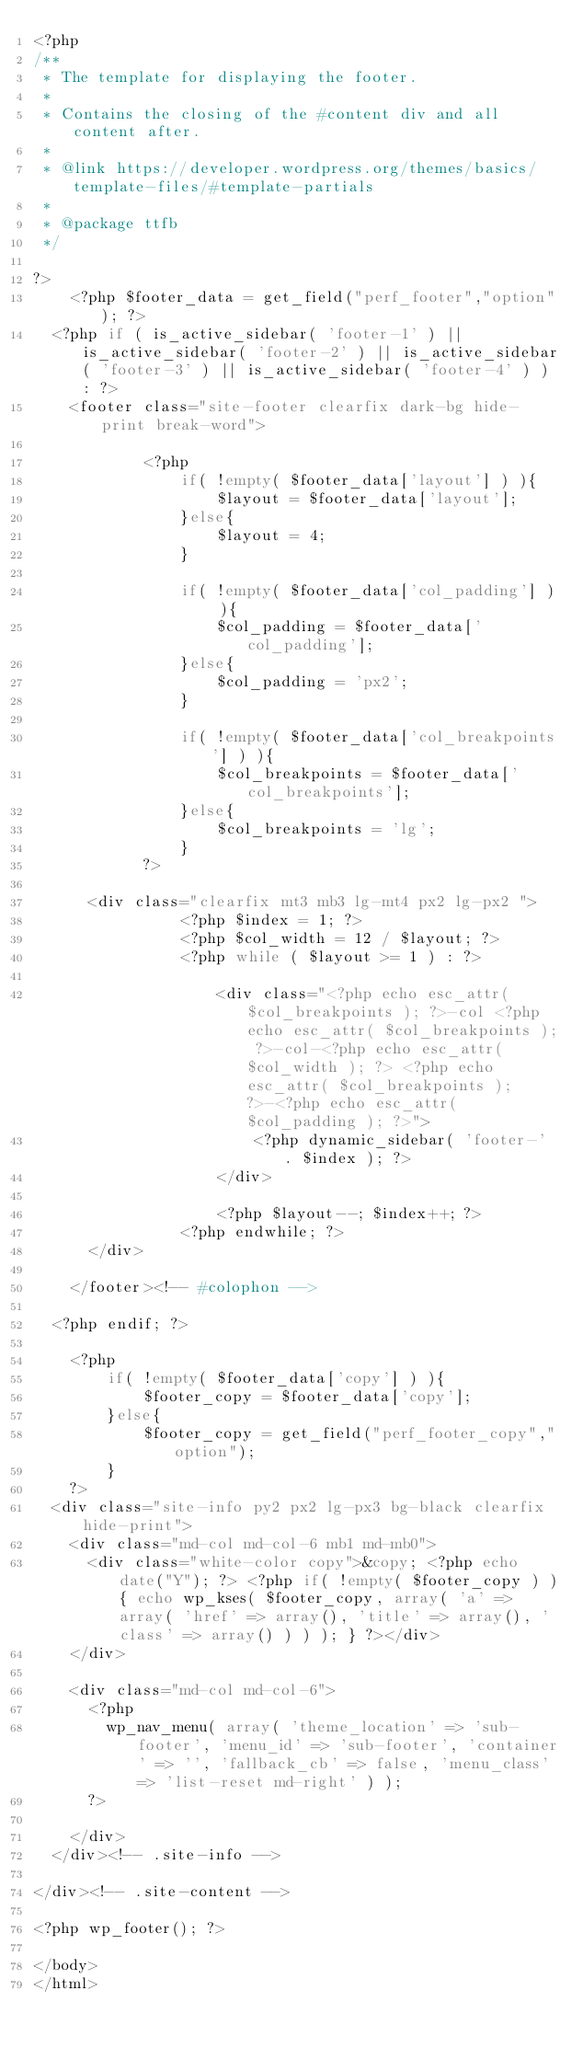Convert code to text. <code><loc_0><loc_0><loc_500><loc_500><_PHP_><?php
/**
 * The template for displaying the footer.
 *
 * Contains the closing of the #content div and all content after.
 *
 * @link https://developer.wordpress.org/themes/basics/template-files/#template-partials
 *
 * @package ttfb
 */

?>
    <?php $footer_data = get_field("perf_footer","option"); ?>
	<?php if ( is_active_sidebar( 'footer-1' ) || is_active_sidebar( 'footer-2' ) || is_active_sidebar( 'footer-3' ) || is_active_sidebar( 'footer-4' ) ) : ?>
		<footer class="site-footer clearfix dark-bg hide-print break-word">

            <?php 
                if( !empty( $footer_data['layout'] ) ){
                    $layout = $footer_data['layout'];
                }else{
                    $layout = 4;
                }

                if( !empty( $footer_data['col_padding'] ) ){
                    $col_padding = $footer_data['col_padding'];
                }else{
                    $col_padding = 'px2';
                }

                if( !empty( $footer_data['col_breakpoints'] ) ){
                    $col_breakpoints = $footer_data['col_breakpoints'];
                }else{
                    $col_breakpoints = 'lg';
                }
            ?>
            
			<div class="clearfix mt3 mb3 lg-mt4 px2 lg-px2 ">
                <?php $index = 1; ?>
                <?php $col_width = 12 / $layout; ?>
                <?php while ( $layout >= 1 ) : ?>
                
                    <div class="<?php echo esc_attr( $col_breakpoints ); ?>-col <?php echo esc_attr( $col_breakpoints ); ?>-col-<?php echo esc_attr( $col_width ); ?> <?php echo esc_attr( $col_breakpoints ); ?>-<?php echo esc_attr( $col_padding ); ?>">
                        <?php dynamic_sidebar( 'footer-' . $index ); ?>
                    </div>

                    <?php $layout--; $index++; ?>
                <?php endwhile; ?>
			</div>

		</footer><!-- #colophon -->

	<?php endif; ?>
    
    <?php 
        if( !empty( $footer_data['copy'] ) ){
            $footer_copy = $footer_data['copy'];
        }else{
            $footer_copy = get_field("perf_footer_copy","option");
        }
    ?>
	<div class="site-info py2 px2 lg-px3 bg-black clearfix hide-print">
		<div class="md-col md-col-6 mb1 md-mb0">
			<div class="white-color copy">&copy; <?php echo date("Y"); ?> <?php if( !empty( $footer_copy ) ){ echo wp_kses( $footer_copy, array( 'a' => array( 'href' => array(), 'title' => array(), 'class' => array() ) ) ); } ?></div>
		</div>

		<div class="md-col md-col-6">
			<?php
				wp_nav_menu( array( 'theme_location' => 'sub-footer', 'menu_id' => 'sub-footer', 'container' => '', 'fallback_cb' => false, 'menu_class' => 'list-reset md-right' ) );
			?>

		</div>
	</div><!-- .site-info -->

</div><!-- .site-content -->

<?php wp_footer(); ?>

</body>
</html></code> 